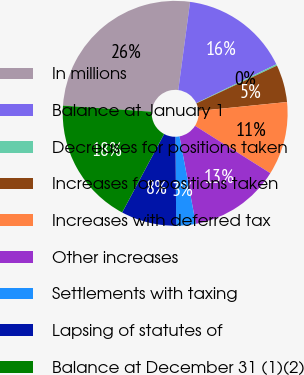Convert chart to OTSL. <chart><loc_0><loc_0><loc_500><loc_500><pie_chart><fcel>In millions<fcel>Balance at January 1<fcel>Decreases for positions taken<fcel>Increases for positions taken<fcel>Increases with deferred tax<fcel>Other increases<fcel>Settlements with taxing<fcel>Lapsing of statutes of<fcel>Balance at December 31 (1)(2)<nl><fcel>26.03%<fcel>15.7%<fcel>0.21%<fcel>5.37%<fcel>10.54%<fcel>13.12%<fcel>2.79%<fcel>7.96%<fcel>18.28%<nl></chart> 